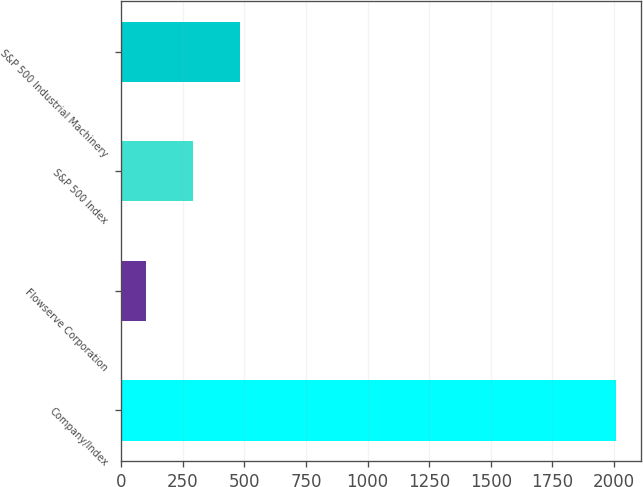Convert chart to OTSL. <chart><loc_0><loc_0><loc_500><loc_500><bar_chart><fcel>Company/Index<fcel>Flowserve Corporation<fcel>S&P 500 Index<fcel>S&P 500 Industrial Machinery<nl><fcel>2008<fcel>100<fcel>290.8<fcel>481.6<nl></chart> 